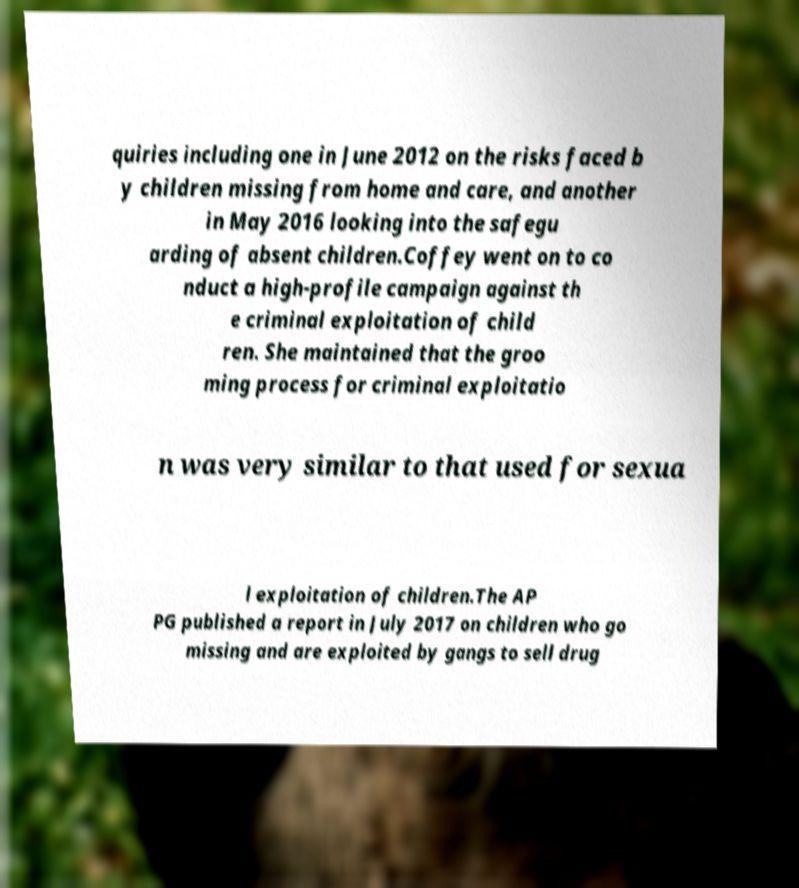What messages or text are displayed in this image? I need them in a readable, typed format. quiries including one in June 2012 on the risks faced b y children missing from home and care, and another in May 2016 looking into the safegu arding of absent children.Coffey went on to co nduct a high-profile campaign against th e criminal exploitation of child ren. She maintained that the groo ming process for criminal exploitatio n was very similar to that used for sexua l exploitation of children.The AP PG published a report in July 2017 on children who go missing and are exploited by gangs to sell drug 